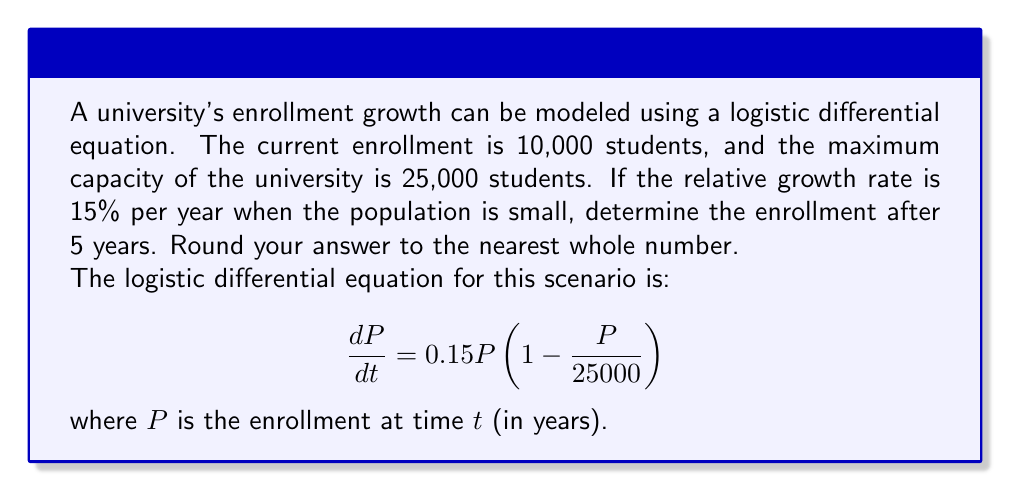Show me your answer to this math problem. To solve this problem, we need to use the solution to the logistic differential equation:

$$P(t) = \frac{K}{1 + (\frac{K}{P_0} - 1)e^{-rt}}$$

Where:
$K$ is the carrying capacity (maximum enrollment)
$P_0$ is the initial enrollment
$r$ is the relative growth rate
$t$ is the time in years

Given:
$K = 25000$
$P_0 = 10000$
$r = 0.15$
$t = 5$

Let's substitute these values into the equation:

$$P(5) = \frac{25000}{1 + (\frac{25000}{10000} - 1)e^{-0.15(5)}}$$

$$P(5) = \frac{25000}{1 + (2.5 - 1)e^{-0.75}}$$

$$P(5) = \frac{25000}{1 + 1.5e^{-0.75}}$$

Now, let's calculate this step by step:

1. Calculate $e^{-0.75}$:
   $e^{-0.75} \approx 0.4724$

2. Multiply by 1.5:
   $1.5 * 0.4724 \approx 0.7086$

3. Add 1:
   $1 + 0.7086 = 1.7086$

4. Divide 25000 by this result:
   $\frac{25000}{1.7086} \approx 14631.57$

5. Round to the nearest whole number:
   14632
Answer: 14632 students 